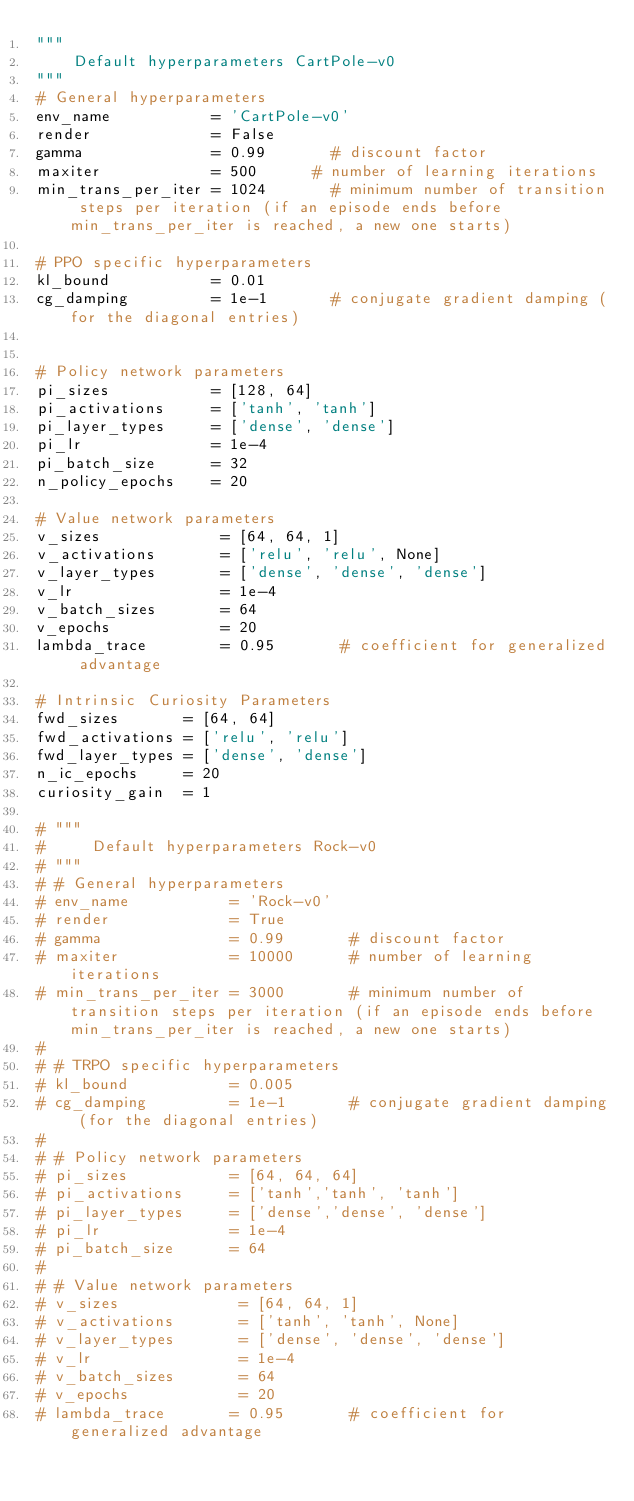Convert code to text. <code><loc_0><loc_0><loc_500><loc_500><_Python_>"""
    Default hyperparameters CartPole-v0
"""
# General hyperparameters
env_name           = 'CartPole-v0'
render             = False
gamma              = 0.99       # discount factor
maxiter            = 500      # number of learning iterations
min_trans_per_iter = 1024       # minimum number of transition steps per iteration (if an episode ends before min_trans_per_iter is reached, a new one starts)

# PPO specific hyperparameters
kl_bound           = 0.01
cg_damping         = 1e-1       # conjugate gradient damping (for the diagonal entries)


# Policy network parameters
pi_sizes           = [128, 64]
pi_activations     = ['tanh', 'tanh']
pi_layer_types     = ['dense', 'dense']
pi_lr              = 1e-4
pi_batch_size      = 32
n_policy_epochs    = 20

# Value network parameters
v_sizes             = [64, 64, 1]
v_activations       = ['relu', 'relu', None]
v_layer_types       = ['dense', 'dense', 'dense']
v_lr                = 1e-4
v_batch_sizes       = 64
v_epochs            = 20
lambda_trace        = 0.95       # coefficient for generalized advantage

# Intrinsic Curiosity Parameters
fwd_sizes       = [64, 64]
fwd_activations = ['relu', 'relu']
fwd_layer_types = ['dense', 'dense']
n_ic_epochs     = 20
curiosity_gain  = 1

# """
#     Default hyperparameters Rock-v0
# """
# # General hyperparameters
# env_name           = 'Rock-v0'
# render             = True
# gamma              = 0.99       # discount factor
# maxiter            = 10000      # number of learning iterations
# min_trans_per_iter = 3000       # minimum number of transition steps per iteration (if an episode ends before min_trans_per_iter is reached, a new one starts)
#
# # TRPO specific hyperparameters
# kl_bound           = 0.005
# cg_damping         = 1e-1       # conjugate gradient damping (for the diagonal entries)
#
# # Policy network parameters
# pi_sizes           = [64, 64, 64]
# pi_activations     = ['tanh','tanh', 'tanh']
# pi_layer_types     = ['dense','dense', 'dense']
# pi_lr              = 1e-4
# pi_batch_size      = 64
#
# # Value network parameters
# v_sizes             = [64, 64, 1]
# v_activations       = ['tanh', 'tanh', None]
# v_layer_types       = ['dense', 'dense', 'dense']
# v_lr                = 1e-4
# v_batch_sizes       = 64
# v_epochs            = 20
# lambda_trace       = 0.95       # coefficient for generalized advantage
</code> 